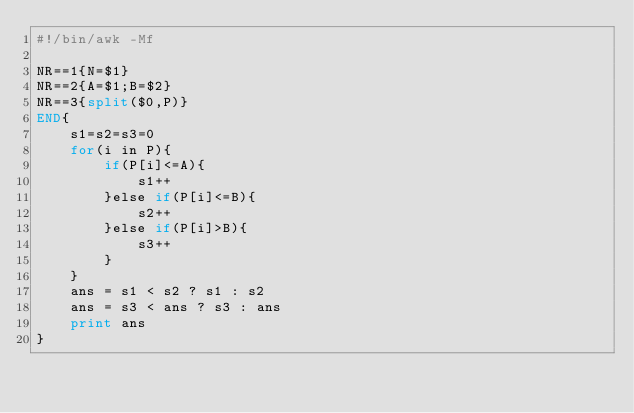<code> <loc_0><loc_0><loc_500><loc_500><_Awk_>#!/bin/awk -Mf

NR==1{N=$1}
NR==2{A=$1;B=$2}
NR==3{split($0,P)}
END{
    s1=s2=s3=0
    for(i in P){
        if(P[i]<=A){
            s1++
        }else if(P[i]<=B){
            s2++
        }else if(P[i]>B){
            s3++
        }
    }
    ans = s1 < s2 ? s1 : s2
    ans = s3 < ans ? s3 : ans
    print ans
}
</code> 